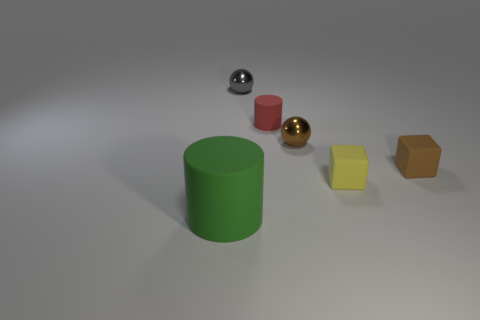What number of things are big green cylinders or small yellow objects?
Keep it short and to the point. 2. Does the thing that is in front of the yellow object have the same color as the cube that is on the right side of the tiny yellow rubber object?
Provide a short and direct response. No. There is a gray shiny thing that is the same size as the brown matte block; what shape is it?
Ensure brevity in your answer.  Sphere. What number of things are cylinders in front of the red matte thing or objects to the left of the small brown ball?
Offer a terse response. 3. Are there fewer objects than small red shiny objects?
Make the answer very short. No. What is the material of the gray object that is the same size as the brown ball?
Provide a succinct answer. Metal. There is a block in front of the tiny brown block; does it have the same size as the matte cylinder that is left of the small red matte cylinder?
Give a very brief answer. No. Are there any gray spheres that have the same material as the brown ball?
Your answer should be very brief. Yes. How many things are either cylinders that are in front of the tiny brown metal thing or blue objects?
Your response must be concise. 1. Do the tiny gray ball that is behind the tiny yellow object and the brown sphere have the same material?
Keep it short and to the point. Yes. 